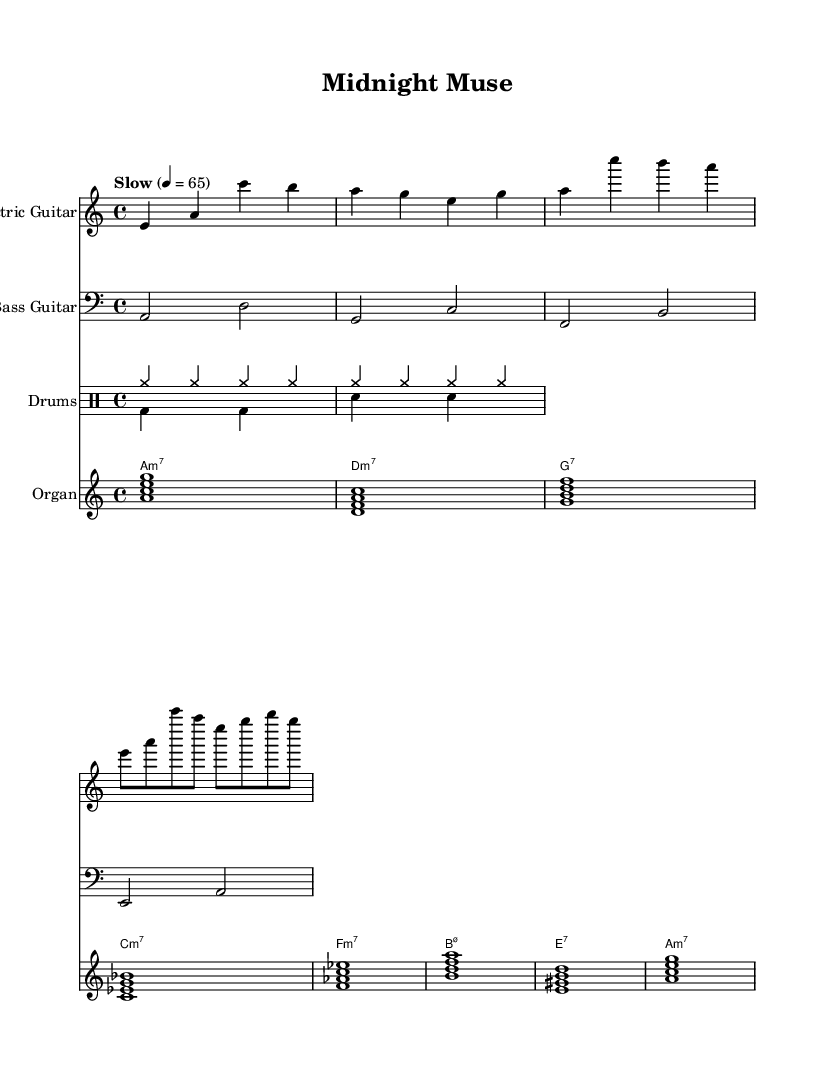What is the key signature of this music? The key signature indicates the piece is in A minor, which has no sharps or flats. In the sheet music, this is represented by the lack of any accidentals at the beginning.
Answer: A minor What is the time signature of this music? The time signature is 4/4, which means there are four beats in each measure, and the quarter note gets one beat. This is clearly notated in the sheet music at the beginning of the score.
Answer: 4/4 What is the tempo marking of this piece? The tempo marking is "Slow" with a indicated bpm of 65, which guides how fast the music should be played. This is shown at the beginning of the score next to the time signature.
Answer: 65 How many measures are in the electric guitar part? The electric guitar part consists of 4 measures in the provided music, which can be counted by looking at the number of vertical bar lines present in the music staff.
Answer: 4 What type of seventh chord is used in the organ part on the first measure? The first chord in the organ part is an A minor seventh chord, indicated by the symbol a:m7. This shows it is built on the root note A with a minor third, perfect fifth, and minor seventh.
Answer: A minor seventh How many different drum patterns are indicated in the score? There are two distinctive drum patterns in the score: one for the cymbals listed as "drumsUp" and one for the bass and snare drums marked as "drumsDown." These two separate sections highlight different rhythmic elements in the composition.
Answer: 2 What rhythmic feel does this piece primarily convey based on the tempo and genre? The piece has a smooth, laid-back feel characterized by the combination of a slow tempo, swung rhythms, and the improvisational nature typical of Electric Blues. This is inferred from the overall structure and laid-back vibe of the guitar and organ parts.
Answer: Smooth 